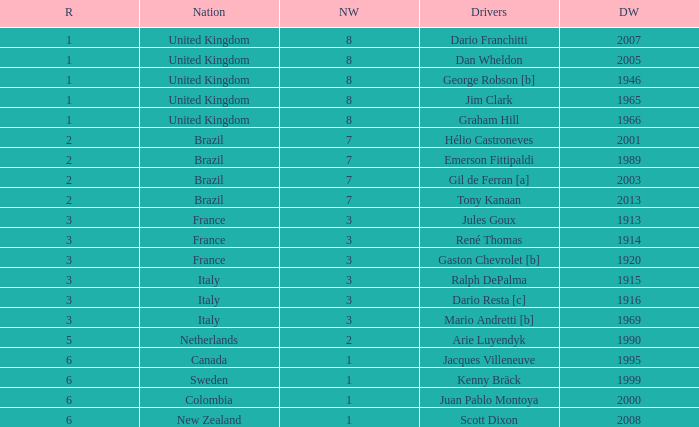What is the average number of wins of drivers from Sweden? 1999.0. 